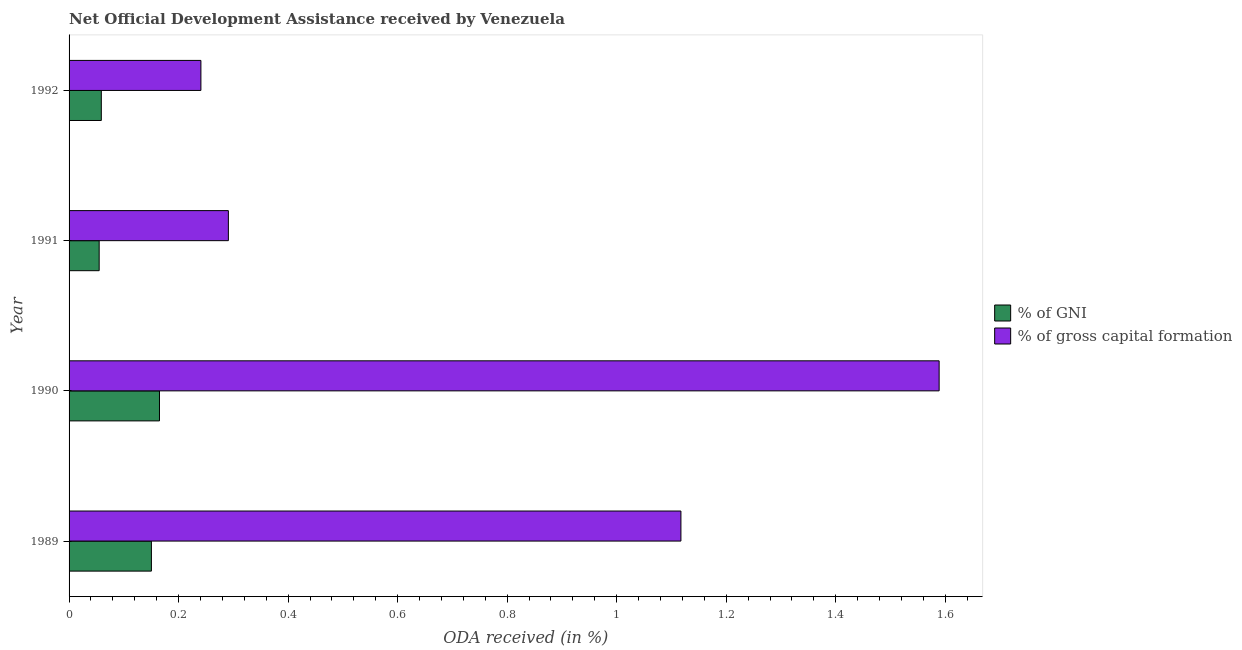How many different coloured bars are there?
Offer a terse response. 2. How many groups of bars are there?
Provide a short and direct response. 4. Are the number of bars on each tick of the Y-axis equal?
Offer a terse response. Yes. How many bars are there on the 4th tick from the top?
Offer a very short reply. 2. How many bars are there on the 4th tick from the bottom?
Ensure brevity in your answer.  2. What is the label of the 4th group of bars from the top?
Give a very brief answer. 1989. In how many cases, is the number of bars for a given year not equal to the number of legend labels?
Offer a terse response. 0. What is the oda received as percentage of gni in 1989?
Provide a succinct answer. 0.15. Across all years, what is the maximum oda received as percentage of gni?
Provide a short and direct response. 0.17. Across all years, what is the minimum oda received as percentage of gni?
Keep it short and to the point. 0.05. In which year was the oda received as percentage of gross capital formation minimum?
Keep it short and to the point. 1992. What is the total oda received as percentage of gni in the graph?
Offer a very short reply. 0.43. What is the difference between the oda received as percentage of gni in 1989 and that in 1990?
Provide a short and direct response. -0.01. What is the difference between the oda received as percentage of gni in 1989 and the oda received as percentage of gross capital formation in 1991?
Provide a short and direct response. -0.14. What is the average oda received as percentage of gni per year?
Your answer should be compact. 0.11. In the year 1991, what is the difference between the oda received as percentage of gni and oda received as percentage of gross capital formation?
Provide a short and direct response. -0.24. What is the ratio of the oda received as percentage of gni in 1991 to that in 1992?
Give a very brief answer. 0.93. Is the oda received as percentage of gross capital formation in 1989 less than that in 1990?
Provide a succinct answer. Yes. What is the difference between the highest and the second highest oda received as percentage of gross capital formation?
Offer a terse response. 0.47. What is the difference between the highest and the lowest oda received as percentage of gross capital formation?
Keep it short and to the point. 1.35. What does the 1st bar from the top in 1990 represents?
Ensure brevity in your answer.  % of gross capital formation. What does the 1st bar from the bottom in 1990 represents?
Your response must be concise. % of GNI. How many bars are there?
Keep it short and to the point. 8. Are all the bars in the graph horizontal?
Your response must be concise. Yes. How many years are there in the graph?
Provide a succinct answer. 4. Are the values on the major ticks of X-axis written in scientific E-notation?
Offer a terse response. No. Where does the legend appear in the graph?
Make the answer very short. Center right. How many legend labels are there?
Offer a terse response. 2. How are the legend labels stacked?
Offer a terse response. Vertical. What is the title of the graph?
Provide a short and direct response. Net Official Development Assistance received by Venezuela. Does "Urban agglomerations" appear as one of the legend labels in the graph?
Offer a very short reply. No. What is the label or title of the X-axis?
Your answer should be compact. ODA received (in %). What is the ODA received (in %) of % of GNI in 1989?
Offer a very short reply. 0.15. What is the ODA received (in %) of % of gross capital formation in 1989?
Make the answer very short. 1.12. What is the ODA received (in %) in % of GNI in 1990?
Provide a succinct answer. 0.17. What is the ODA received (in %) of % of gross capital formation in 1990?
Your response must be concise. 1.59. What is the ODA received (in %) in % of GNI in 1991?
Your answer should be very brief. 0.05. What is the ODA received (in %) of % of gross capital formation in 1991?
Make the answer very short. 0.29. What is the ODA received (in %) in % of GNI in 1992?
Give a very brief answer. 0.06. What is the ODA received (in %) of % of gross capital formation in 1992?
Ensure brevity in your answer.  0.24. Across all years, what is the maximum ODA received (in %) in % of GNI?
Your response must be concise. 0.17. Across all years, what is the maximum ODA received (in %) in % of gross capital formation?
Offer a terse response. 1.59. Across all years, what is the minimum ODA received (in %) of % of GNI?
Provide a succinct answer. 0.05. Across all years, what is the minimum ODA received (in %) of % of gross capital formation?
Provide a short and direct response. 0.24. What is the total ODA received (in %) of % of GNI in the graph?
Your response must be concise. 0.43. What is the total ODA received (in %) in % of gross capital formation in the graph?
Give a very brief answer. 3.24. What is the difference between the ODA received (in %) of % of GNI in 1989 and that in 1990?
Provide a succinct answer. -0.01. What is the difference between the ODA received (in %) in % of gross capital formation in 1989 and that in 1990?
Offer a terse response. -0.47. What is the difference between the ODA received (in %) of % of GNI in 1989 and that in 1991?
Offer a very short reply. 0.1. What is the difference between the ODA received (in %) of % of gross capital formation in 1989 and that in 1991?
Your answer should be very brief. 0.83. What is the difference between the ODA received (in %) in % of GNI in 1989 and that in 1992?
Offer a very short reply. 0.09. What is the difference between the ODA received (in %) in % of gross capital formation in 1989 and that in 1992?
Offer a terse response. 0.88. What is the difference between the ODA received (in %) of % of GNI in 1990 and that in 1991?
Your response must be concise. 0.11. What is the difference between the ODA received (in %) in % of gross capital formation in 1990 and that in 1991?
Provide a short and direct response. 1.3. What is the difference between the ODA received (in %) of % of GNI in 1990 and that in 1992?
Make the answer very short. 0.11. What is the difference between the ODA received (in %) in % of gross capital formation in 1990 and that in 1992?
Provide a short and direct response. 1.35. What is the difference between the ODA received (in %) in % of GNI in 1991 and that in 1992?
Keep it short and to the point. -0. What is the difference between the ODA received (in %) of % of gross capital formation in 1991 and that in 1992?
Keep it short and to the point. 0.05. What is the difference between the ODA received (in %) of % of GNI in 1989 and the ODA received (in %) of % of gross capital formation in 1990?
Your response must be concise. -1.44. What is the difference between the ODA received (in %) of % of GNI in 1989 and the ODA received (in %) of % of gross capital formation in 1991?
Ensure brevity in your answer.  -0.14. What is the difference between the ODA received (in %) of % of GNI in 1989 and the ODA received (in %) of % of gross capital formation in 1992?
Provide a succinct answer. -0.09. What is the difference between the ODA received (in %) in % of GNI in 1990 and the ODA received (in %) in % of gross capital formation in 1991?
Make the answer very short. -0.13. What is the difference between the ODA received (in %) in % of GNI in 1990 and the ODA received (in %) in % of gross capital formation in 1992?
Make the answer very short. -0.08. What is the difference between the ODA received (in %) in % of GNI in 1991 and the ODA received (in %) in % of gross capital formation in 1992?
Make the answer very short. -0.19. What is the average ODA received (in %) of % of GNI per year?
Give a very brief answer. 0.11. What is the average ODA received (in %) of % of gross capital formation per year?
Ensure brevity in your answer.  0.81. In the year 1989, what is the difference between the ODA received (in %) of % of GNI and ODA received (in %) of % of gross capital formation?
Give a very brief answer. -0.97. In the year 1990, what is the difference between the ODA received (in %) of % of GNI and ODA received (in %) of % of gross capital formation?
Provide a succinct answer. -1.42. In the year 1991, what is the difference between the ODA received (in %) of % of GNI and ODA received (in %) of % of gross capital formation?
Your answer should be compact. -0.24. In the year 1992, what is the difference between the ODA received (in %) of % of GNI and ODA received (in %) of % of gross capital formation?
Your answer should be compact. -0.18. What is the ratio of the ODA received (in %) in % of GNI in 1989 to that in 1990?
Give a very brief answer. 0.91. What is the ratio of the ODA received (in %) of % of gross capital formation in 1989 to that in 1990?
Provide a short and direct response. 0.7. What is the ratio of the ODA received (in %) in % of GNI in 1989 to that in 1991?
Ensure brevity in your answer.  2.74. What is the ratio of the ODA received (in %) in % of gross capital formation in 1989 to that in 1991?
Make the answer very short. 3.84. What is the ratio of the ODA received (in %) of % of GNI in 1989 to that in 1992?
Your answer should be compact. 2.55. What is the ratio of the ODA received (in %) of % of gross capital formation in 1989 to that in 1992?
Provide a short and direct response. 4.64. What is the ratio of the ODA received (in %) in % of GNI in 1990 to that in 1991?
Keep it short and to the point. 3. What is the ratio of the ODA received (in %) in % of gross capital formation in 1990 to that in 1991?
Give a very brief answer. 5.46. What is the ratio of the ODA received (in %) of % of GNI in 1990 to that in 1992?
Provide a short and direct response. 2.8. What is the ratio of the ODA received (in %) in % of gross capital formation in 1990 to that in 1992?
Keep it short and to the point. 6.6. What is the ratio of the ODA received (in %) of % of GNI in 1991 to that in 1992?
Offer a terse response. 0.93. What is the ratio of the ODA received (in %) of % of gross capital formation in 1991 to that in 1992?
Your answer should be compact. 1.21. What is the difference between the highest and the second highest ODA received (in %) in % of GNI?
Offer a very short reply. 0.01. What is the difference between the highest and the second highest ODA received (in %) in % of gross capital formation?
Your answer should be very brief. 0.47. What is the difference between the highest and the lowest ODA received (in %) of % of GNI?
Make the answer very short. 0.11. What is the difference between the highest and the lowest ODA received (in %) in % of gross capital formation?
Make the answer very short. 1.35. 